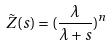Convert formula to latex. <formula><loc_0><loc_0><loc_500><loc_500>\tilde { Z } ( s ) = ( \frac { \lambda } { \lambda + s } ) ^ { n }</formula> 